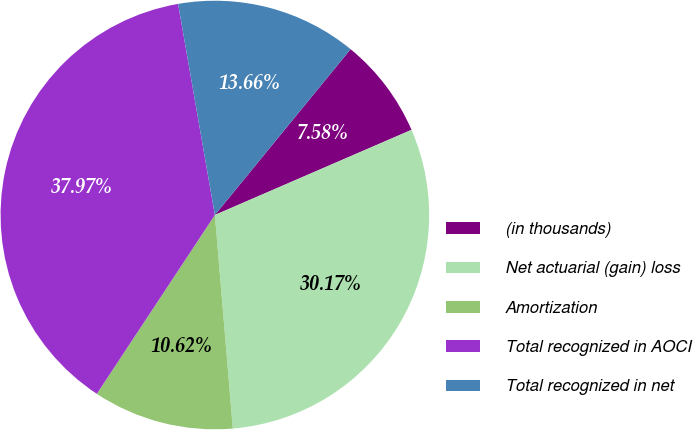Convert chart. <chart><loc_0><loc_0><loc_500><loc_500><pie_chart><fcel>(in thousands)<fcel>Net actuarial (gain) loss<fcel>Amortization<fcel>Total recognized in AOCI<fcel>Total recognized in net<nl><fcel>7.58%<fcel>30.17%<fcel>10.62%<fcel>37.97%<fcel>13.66%<nl></chart> 